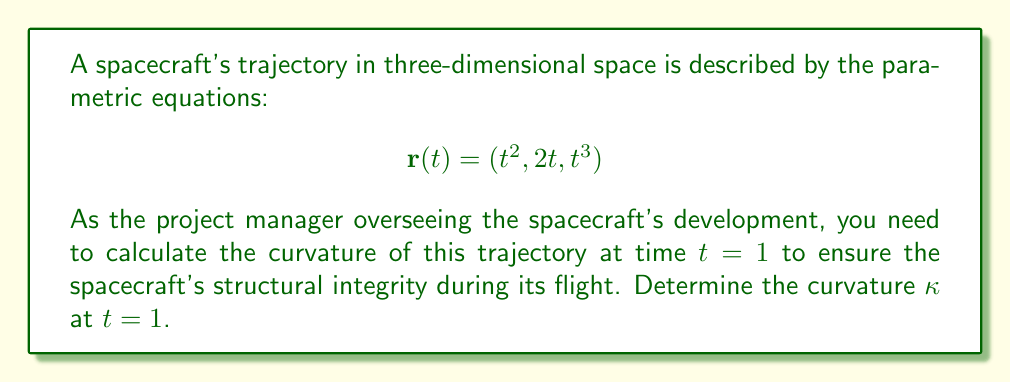Solve this math problem. To calculate the curvature of the spacecraft's trajectory, we'll follow these steps:

1. Calculate the first derivative $r'(t)$:
   $$r'(t) = (2t, 2, 3t^2)$$

2. Calculate the second derivative $r''(t)$:
   $$r''(t) = (2, 0, 6t)$$

3. Calculate the magnitude of $r'(t)$ at $t=1$:
   $$\|r'(1)\| = \sqrt{(2)^2 + 2^2 + (3)^2} = \sqrt{4 + 4 + 9} = \sqrt{17}$$

4. Calculate the cross product of $r'(t)$ and $r''(t)$ at $t=1$:
   $$r'(1) \times r''(1) = (2, 2, 3) \times (2, 0, 6) = (12, -6, -4)$$

5. Calculate the magnitude of this cross product:
   $$\|r'(1) \times r''(1)\| = \sqrt{12^2 + (-6)^2 + (-4)^2} = \sqrt{144 + 36 + 16} = \sqrt{196} = 14$$

6. Apply the curvature formula:
   $$\kappa = \frac{\|r'(t) \times r''(t)\|}{\|r'(t)\|^3}$$

   Substituting the values at $t=1$:
   $$\kappa = \frac{14}{(\sqrt{17})^3} = \frac{14}{17\sqrt{17}}$$

Therefore, the curvature of the spacecraft's trajectory at $t=1$ is $\frac{14}{17\sqrt{17}}$.
Answer: $\frac{14}{17\sqrt{17}}$ 